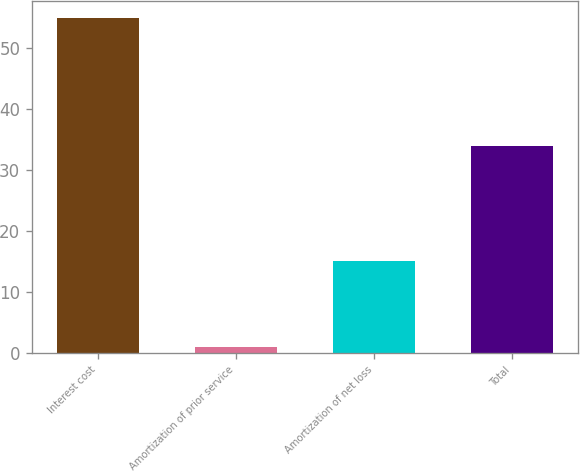Convert chart. <chart><loc_0><loc_0><loc_500><loc_500><bar_chart><fcel>Interest cost<fcel>Amortization of prior service<fcel>Amortization of net loss<fcel>Total<nl><fcel>55<fcel>1<fcel>15<fcel>34<nl></chart> 